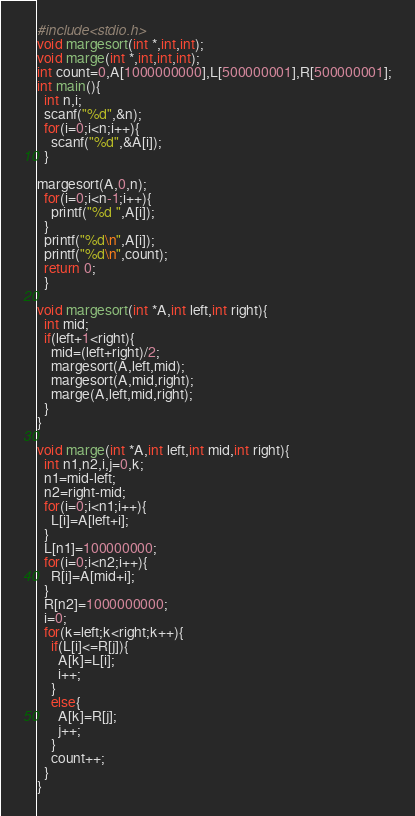Convert code to text. <code><loc_0><loc_0><loc_500><loc_500><_C_>#include<stdio.h>
void margesort(int *,int,int);
void marge(int *,int,int,int);
int count=0,A[1000000000],L[500000001],R[500000001];
int main(){
  int n,i;
  scanf("%d",&n);
  for(i=0;i<n;i++){
    scanf("%d",&A[i]);
  }

margesort(A,0,n);
  for(i=0;i<n-1;i++){
    printf("%d ",A[i]);
  }
  printf("%d\n",A[i]);
  printf("%d\n",count);
  return 0;
  }

void margesort(int *A,int left,int right){
  int mid;
  if(left+1<right){
    mid=(left+right)/2;
    margesort(A,left,mid);
    margesort(A,mid,right);
    marge(A,left,mid,right);
  }
}

void marge(int *A,int left,int mid,int right){
  int n1,n2,i,j=0,k;
  n1=mid-left;
  n2=right-mid;
  for(i=0;i<n1;i++){
    L[i]=A[left+i];
  }
  L[n1]=100000000;
  for(i=0;i<n2;i++){
    R[i]=A[mid+i];
  }
  R[n2]=1000000000;
  i=0;
  for(k=left;k<right;k++){
    if(L[i]<=R[j]){
      A[k]=L[i];
      i++;
    }
    else{
      A[k]=R[j];
      j++;
    }
    count++;
  }
}

</code> 